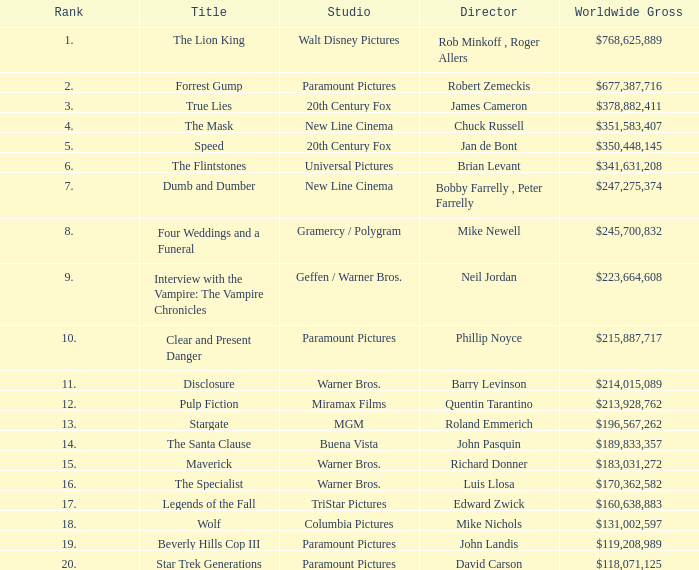What is the position of the movie that has a worldwide gross of $183,031,272 in the ranking? 15.0. 